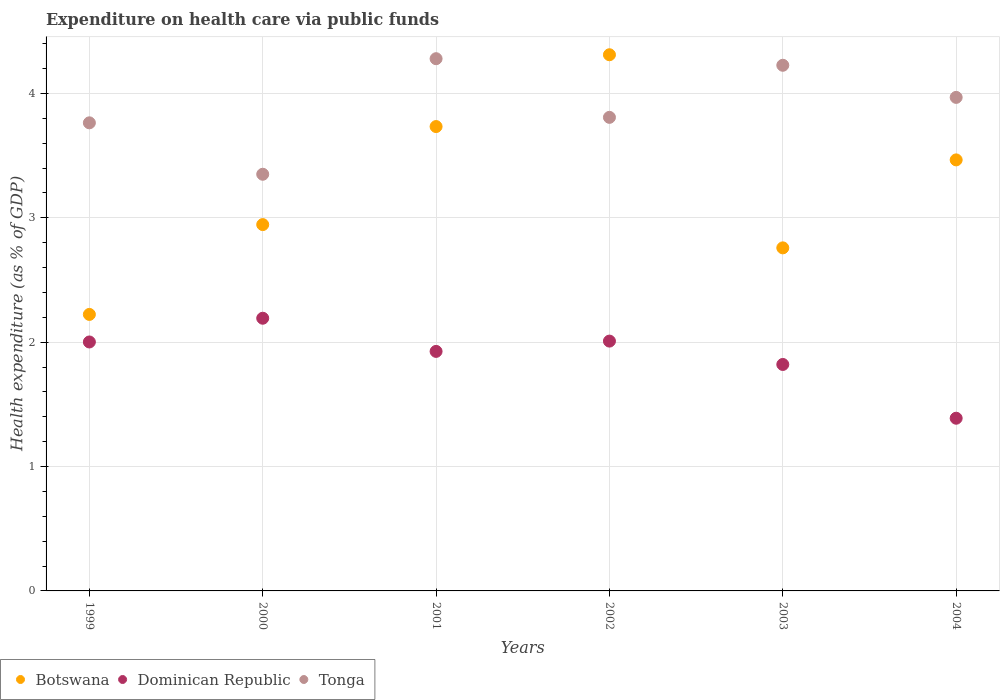How many different coloured dotlines are there?
Give a very brief answer. 3. What is the expenditure made on health care in Tonga in 1999?
Give a very brief answer. 3.76. Across all years, what is the maximum expenditure made on health care in Tonga?
Offer a terse response. 4.28. Across all years, what is the minimum expenditure made on health care in Dominican Republic?
Ensure brevity in your answer.  1.39. What is the total expenditure made on health care in Dominican Republic in the graph?
Offer a terse response. 11.34. What is the difference between the expenditure made on health care in Botswana in 2001 and that in 2003?
Provide a short and direct response. 0.98. What is the difference between the expenditure made on health care in Tonga in 2002 and the expenditure made on health care in Dominican Republic in 1999?
Make the answer very short. 1.81. What is the average expenditure made on health care in Tonga per year?
Make the answer very short. 3.9. In the year 2000, what is the difference between the expenditure made on health care in Botswana and expenditure made on health care in Tonga?
Offer a very short reply. -0.4. In how many years, is the expenditure made on health care in Dominican Republic greater than 0.6000000000000001 %?
Keep it short and to the point. 6. What is the ratio of the expenditure made on health care in Dominican Republic in 2001 to that in 2002?
Provide a succinct answer. 0.96. Is the expenditure made on health care in Botswana in 1999 less than that in 2001?
Your response must be concise. Yes. Is the difference between the expenditure made on health care in Botswana in 1999 and 2000 greater than the difference between the expenditure made on health care in Tonga in 1999 and 2000?
Your answer should be very brief. No. What is the difference between the highest and the second highest expenditure made on health care in Botswana?
Your response must be concise. 0.58. What is the difference between the highest and the lowest expenditure made on health care in Botswana?
Your response must be concise. 2.09. In how many years, is the expenditure made on health care in Tonga greater than the average expenditure made on health care in Tonga taken over all years?
Your answer should be compact. 3. Is the sum of the expenditure made on health care in Tonga in 1999 and 2001 greater than the maximum expenditure made on health care in Botswana across all years?
Make the answer very short. Yes. Is it the case that in every year, the sum of the expenditure made on health care in Tonga and expenditure made on health care in Dominican Republic  is greater than the expenditure made on health care in Botswana?
Your answer should be compact. Yes. Does the expenditure made on health care in Botswana monotonically increase over the years?
Offer a terse response. No. Is the expenditure made on health care in Tonga strictly greater than the expenditure made on health care in Dominican Republic over the years?
Your answer should be compact. Yes. What is the difference between two consecutive major ticks on the Y-axis?
Keep it short and to the point. 1. Are the values on the major ticks of Y-axis written in scientific E-notation?
Provide a short and direct response. No. Does the graph contain any zero values?
Your answer should be very brief. No. Does the graph contain grids?
Make the answer very short. Yes. Where does the legend appear in the graph?
Give a very brief answer. Bottom left. How many legend labels are there?
Offer a terse response. 3. What is the title of the graph?
Offer a very short reply. Expenditure on health care via public funds. Does "Sub-Saharan Africa (all income levels)" appear as one of the legend labels in the graph?
Your answer should be compact. No. What is the label or title of the X-axis?
Your answer should be very brief. Years. What is the label or title of the Y-axis?
Your answer should be compact. Health expenditure (as % of GDP). What is the Health expenditure (as % of GDP) of Botswana in 1999?
Provide a short and direct response. 2.22. What is the Health expenditure (as % of GDP) of Dominican Republic in 1999?
Offer a terse response. 2. What is the Health expenditure (as % of GDP) of Tonga in 1999?
Your answer should be compact. 3.76. What is the Health expenditure (as % of GDP) in Botswana in 2000?
Your answer should be very brief. 2.95. What is the Health expenditure (as % of GDP) of Dominican Republic in 2000?
Your response must be concise. 2.19. What is the Health expenditure (as % of GDP) of Tonga in 2000?
Ensure brevity in your answer.  3.35. What is the Health expenditure (as % of GDP) in Botswana in 2001?
Offer a terse response. 3.73. What is the Health expenditure (as % of GDP) in Dominican Republic in 2001?
Offer a very short reply. 1.93. What is the Health expenditure (as % of GDP) of Tonga in 2001?
Give a very brief answer. 4.28. What is the Health expenditure (as % of GDP) of Botswana in 2002?
Make the answer very short. 4.31. What is the Health expenditure (as % of GDP) of Dominican Republic in 2002?
Your answer should be very brief. 2.01. What is the Health expenditure (as % of GDP) in Tonga in 2002?
Give a very brief answer. 3.81. What is the Health expenditure (as % of GDP) of Botswana in 2003?
Your answer should be very brief. 2.76. What is the Health expenditure (as % of GDP) of Dominican Republic in 2003?
Offer a terse response. 1.82. What is the Health expenditure (as % of GDP) of Tonga in 2003?
Provide a short and direct response. 4.23. What is the Health expenditure (as % of GDP) of Botswana in 2004?
Ensure brevity in your answer.  3.47. What is the Health expenditure (as % of GDP) of Dominican Republic in 2004?
Provide a short and direct response. 1.39. What is the Health expenditure (as % of GDP) in Tonga in 2004?
Your answer should be compact. 3.97. Across all years, what is the maximum Health expenditure (as % of GDP) in Botswana?
Your answer should be compact. 4.31. Across all years, what is the maximum Health expenditure (as % of GDP) in Dominican Republic?
Give a very brief answer. 2.19. Across all years, what is the maximum Health expenditure (as % of GDP) of Tonga?
Offer a very short reply. 4.28. Across all years, what is the minimum Health expenditure (as % of GDP) in Botswana?
Give a very brief answer. 2.22. Across all years, what is the minimum Health expenditure (as % of GDP) of Dominican Republic?
Ensure brevity in your answer.  1.39. Across all years, what is the minimum Health expenditure (as % of GDP) of Tonga?
Offer a terse response. 3.35. What is the total Health expenditure (as % of GDP) of Botswana in the graph?
Provide a short and direct response. 19.44. What is the total Health expenditure (as % of GDP) in Dominican Republic in the graph?
Offer a very short reply. 11.34. What is the total Health expenditure (as % of GDP) in Tonga in the graph?
Offer a terse response. 23.4. What is the difference between the Health expenditure (as % of GDP) of Botswana in 1999 and that in 2000?
Provide a succinct answer. -0.72. What is the difference between the Health expenditure (as % of GDP) of Dominican Republic in 1999 and that in 2000?
Your answer should be compact. -0.19. What is the difference between the Health expenditure (as % of GDP) in Tonga in 1999 and that in 2000?
Keep it short and to the point. 0.41. What is the difference between the Health expenditure (as % of GDP) of Botswana in 1999 and that in 2001?
Ensure brevity in your answer.  -1.51. What is the difference between the Health expenditure (as % of GDP) of Dominican Republic in 1999 and that in 2001?
Provide a short and direct response. 0.08. What is the difference between the Health expenditure (as % of GDP) of Tonga in 1999 and that in 2001?
Your response must be concise. -0.52. What is the difference between the Health expenditure (as % of GDP) of Botswana in 1999 and that in 2002?
Offer a very short reply. -2.09. What is the difference between the Health expenditure (as % of GDP) in Dominican Republic in 1999 and that in 2002?
Offer a very short reply. -0.01. What is the difference between the Health expenditure (as % of GDP) of Tonga in 1999 and that in 2002?
Your answer should be compact. -0.04. What is the difference between the Health expenditure (as % of GDP) of Botswana in 1999 and that in 2003?
Provide a succinct answer. -0.54. What is the difference between the Health expenditure (as % of GDP) in Dominican Republic in 1999 and that in 2003?
Keep it short and to the point. 0.18. What is the difference between the Health expenditure (as % of GDP) in Tonga in 1999 and that in 2003?
Keep it short and to the point. -0.46. What is the difference between the Health expenditure (as % of GDP) of Botswana in 1999 and that in 2004?
Ensure brevity in your answer.  -1.24. What is the difference between the Health expenditure (as % of GDP) of Dominican Republic in 1999 and that in 2004?
Ensure brevity in your answer.  0.61. What is the difference between the Health expenditure (as % of GDP) of Tonga in 1999 and that in 2004?
Your response must be concise. -0.2. What is the difference between the Health expenditure (as % of GDP) of Botswana in 2000 and that in 2001?
Give a very brief answer. -0.79. What is the difference between the Health expenditure (as % of GDP) in Dominican Republic in 2000 and that in 2001?
Keep it short and to the point. 0.27. What is the difference between the Health expenditure (as % of GDP) in Tonga in 2000 and that in 2001?
Offer a very short reply. -0.93. What is the difference between the Health expenditure (as % of GDP) in Botswana in 2000 and that in 2002?
Your answer should be very brief. -1.37. What is the difference between the Health expenditure (as % of GDP) in Dominican Republic in 2000 and that in 2002?
Provide a succinct answer. 0.18. What is the difference between the Health expenditure (as % of GDP) in Tonga in 2000 and that in 2002?
Your response must be concise. -0.46. What is the difference between the Health expenditure (as % of GDP) of Botswana in 2000 and that in 2003?
Keep it short and to the point. 0.19. What is the difference between the Health expenditure (as % of GDP) in Dominican Republic in 2000 and that in 2003?
Offer a terse response. 0.37. What is the difference between the Health expenditure (as % of GDP) in Tonga in 2000 and that in 2003?
Give a very brief answer. -0.88. What is the difference between the Health expenditure (as % of GDP) in Botswana in 2000 and that in 2004?
Ensure brevity in your answer.  -0.52. What is the difference between the Health expenditure (as % of GDP) of Dominican Republic in 2000 and that in 2004?
Offer a very short reply. 0.8. What is the difference between the Health expenditure (as % of GDP) of Tonga in 2000 and that in 2004?
Make the answer very short. -0.62. What is the difference between the Health expenditure (as % of GDP) of Botswana in 2001 and that in 2002?
Give a very brief answer. -0.58. What is the difference between the Health expenditure (as % of GDP) of Dominican Republic in 2001 and that in 2002?
Provide a succinct answer. -0.08. What is the difference between the Health expenditure (as % of GDP) of Tonga in 2001 and that in 2002?
Ensure brevity in your answer.  0.47. What is the difference between the Health expenditure (as % of GDP) in Botswana in 2001 and that in 2003?
Your answer should be very brief. 0.98. What is the difference between the Health expenditure (as % of GDP) in Dominican Republic in 2001 and that in 2003?
Keep it short and to the point. 0.11. What is the difference between the Health expenditure (as % of GDP) in Tonga in 2001 and that in 2003?
Your response must be concise. 0.05. What is the difference between the Health expenditure (as % of GDP) of Botswana in 2001 and that in 2004?
Your response must be concise. 0.27. What is the difference between the Health expenditure (as % of GDP) of Dominican Republic in 2001 and that in 2004?
Offer a very short reply. 0.54. What is the difference between the Health expenditure (as % of GDP) in Tonga in 2001 and that in 2004?
Your answer should be compact. 0.31. What is the difference between the Health expenditure (as % of GDP) in Botswana in 2002 and that in 2003?
Offer a very short reply. 1.55. What is the difference between the Health expenditure (as % of GDP) in Dominican Republic in 2002 and that in 2003?
Offer a terse response. 0.19. What is the difference between the Health expenditure (as % of GDP) of Tonga in 2002 and that in 2003?
Give a very brief answer. -0.42. What is the difference between the Health expenditure (as % of GDP) of Botswana in 2002 and that in 2004?
Keep it short and to the point. 0.85. What is the difference between the Health expenditure (as % of GDP) in Dominican Republic in 2002 and that in 2004?
Ensure brevity in your answer.  0.62. What is the difference between the Health expenditure (as % of GDP) in Tonga in 2002 and that in 2004?
Your answer should be compact. -0.16. What is the difference between the Health expenditure (as % of GDP) of Botswana in 2003 and that in 2004?
Your response must be concise. -0.71. What is the difference between the Health expenditure (as % of GDP) of Dominican Republic in 2003 and that in 2004?
Keep it short and to the point. 0.43. What is the difference between the Health expenditure (as % of GDP) of Tonga in 2003 and that in 2004?
Provide a succinct answer. 0.26. What is the difference between the Health expenditure (as % of GDP) in Botswana in 1999 and the Health expenditure (as % of GDP) in Dominican Republic in 2000?
Offer a terse response. 0.03. What is the difference between the Health expenditure (as % of GDP) in Botswana in 1999 and the Health expenditure (as % of GDP) in Tonga in 2000?
Your response must be concise. -1.13. What is the difference between the Health expenditure (as % of GDP) in Dominican Republic in 1999 and the Health expenditure (as % of GDP) in Tonga in 2000?
Offer a very short reply. -1.35. What is the difference between the Health expenditure (as % of GDP) in Botswana in 1999 and the Health expenditure (as % of GDP) in Dominican Republic in 2001?
Offer a very short reply. 0.3. What is the difference between the Health expenditure (as % of GDP) in Botswana in 1999 and the Health expenditure (as % of GDP) in Tonga in 2001?
Your response must be concise. -2.06. What is the difference between the Health expenditure (as % of GDP) of Dominican Republic in 1999 and the Health expenditure (as % of GDP) of Tonga in 2001?
Make the answer very short. -2.28. What is the difference between the Health expenditure (as % of GDP) of Botswana in 1999 and the Health expenditure (as % of GDP) of Dominican Republic in 2002?
Provide a succinct answer. 0.21. What is the difference between the Health expenditure (as % of GDP) in Botswana in 1999 and the Health expenditure (as % of GDP) in Tonga in 2002?
Give a very brief answer. -1.58. What is the difference between the Health expenditure (as % of GDP) in Dominican Republic in 1999 and the Health expenditure (as % of GDP) in Tonga in 2002?
Provide a short and direct response. -1.81. What is the difference between the Health expenditure (as % of GDP) of Botswana in 1999 and the Health expenditure (as % of GDP) of Dominican Republic in 2003?
Offer a terse response. 0.4. What is the difference between the Health expenditure (as % of GDP) in Botswana in 1999 and the Health expenditure (as % of GDP) in Tonga in 2003?
Provide a succinct answer. -2. What is the difference between the Health expenditure (as % of GDP) of Dominican Republic in 1999 and the Health expenditure (as % of GDP) of Tonga in 2003?
Make the answer very short. -2.22. What is the difference between the Health expenditure (as % of GDP) in Botswana in 1999 and the Health expenditure (as % of GDP) in Dominican Republic in 2004?
Offer a very short reply. 0.83. What is the difference between the Health expenditure (as % of GDP) in Botswana in 1999 and the Health expenditure (as % of GDP) in Tonga in 2004?
Offer a terse response. -1.75. What is the difference between the Health expenditure (as % of GDP) of Dominican Republic in 1999 and the Health expenditure (as % of GDP) of Tonga in 2004?
Your answer should be very brief. -1.97. What is the difference between the Health expenditure (as % of GDP) in Botswana in 2000 and the Health expenditure (as % of GDP) in Dominican Republic in 2001?
Your response must be concise. 1.02. What is the difference between the Health expenditure (as % of GDP) of Botswana in 2000 and the Health expenditure (as % of GDP) of Tonga in 2001?
Give a very brief answer. -1.33. What is the difference between the Health expenditure (as % of GDP) in Dominican Republic in 2000 and the Health expenditure (as % of GDP) in Tonga in 2001?
Give a very brief answer. -2.09. What is the difference between the Health expenditure (as % of GDP) of Botswana in 2000 and the Health expenditure (as % of GDP) of Dominican Republic in 2002?
Your answer should be very brief. 0.94. What is the difference between the Health expenditure (as % of GDP) of Botswana in 2000 and the Health expenditure (as % of GDP) of Tonga in 2002?
Your answer should be compact. -0.86. What is the difference between the Health expenditure (as % of GDP) in Dominican Republic in 2000 and the Health expenditure (as % of GDP) in Tonga in 2002?
Provide a succinct answer. -1.62. What is the difference between the Health expenditure (as % of GDP) of Botswana in 2000 and the Health expenditure (as % of GDP) of Dominican Republic in 2003?
Your answer should be compact. 1.12. What is the difference between the Health expenditure (as % of GDP) in Botswana in 2000 and the Health expenditure (as % of GDP) in Tonga in 2003?
Give a very brief answer. -1.28. What is the difference between the Health expenditure (as % of GDP) of Dominican Republic in 2000 and the Health expenditure (as % of GDP) of Tonga in 2003?
Provide a short and direct response. -2.03. What is the difference between the Health expenditure (as % of GDP) in Botswana in 2000 and the Health expenditure (as % of GDP) in Dominican Republic in 2004?
Keep it short and to the point. 1.56. What is the difference between the Health expenditure (as % of GDP) in Botswana in 2000 and the Health expenditure (as % of GDP) in Tonga in 2004?
Your answer should be very brief. -1.02. What is the difference between the Health expenditure (as % of GDP) in Dominican Republic in 2000 and the Health expenditure (as % of GDP) in Tonga in 2004?
Ensure brevity in your answer.  -1.78. What is the difference between the Health expenditure (as % of GDP) in Botswana in 2001 and the Health expenditure (as % of GDP) in Dominican Republic in 2002?
Provide a short and direct response. 1.73. What is the difference between the Health expenditure (as % of GDP) of Botswana in 2001 and the Health expenditure (as % of GDP) of Tonga in 2002?
Your answer should be compact. -0.07. What is the difference between the Health expenditure (as % of GDP) of Dominican Republic in 2001 and the Health expenditure (as % of GDP) of Tonga in 2002?
Offer a very short reply. -1.88. What is the difference between the Health expenditure (as % of GDP) in Botswana in 2001 and the Health expenditure (as % of GDP) in Dominican Republic in 2003?
Keep it short and to the point. 1.91. What is the difference between the Health expenditure (as % of GDP) in Botswana in 2001 and the Health expenditure (as % of GDP) in Tonga in 2003?
Your answer should be very brief. -0.49. What is the difference between the Health expenditure (as % of GDP) in Dominican Republic in 2001 and the Health expenditure (as % of GDP) in Tonga in 2003?
Your answer should be very brief. -2.3. What is the difference between the Health expenditure (as % of GDP) of Botswana in 2001 and the Health expenditure (as % of GDP) of Dominican Republic in 2004?
Give a very brief answer. 2.35. What is the difference between the Health expenditure (as % of GDP) in Botswana in 2001 and the Health expenditure (as % of GDP) in Tonga in 2004?
Offer a very short reply. -0.23. What is the difference between the Health expenditure (as % of GDP) in Dominican Republic in 2001 and the Health expenditure (as % of GDP) in Tonga in 2004?
Provide a short and direct response. -2.04. What is the difference between the Health expenditure (as % of GDP) of Botswana in 2002 and the Health expenditure (as % of GDP) of Dominican Republic in 2003?
Make the answer very short. 2.49. What is the difference between the Health expenditure (as % of GDP) in Botswana in 2002 and the Health expenditure (as % of GDP) in Tonga in 2003?
Provide a succinct answer. 0.08. What is the difference between the Health expenditure (as % of GDP) in Dominican Republic in 2002 and the Health expenditure (as % of GDP) in Tonga in 2003?
Offer a terse response. -2.22. What is the difference between the Health expenditure (as % of GDP) of Botswana in 2002 and the Health expenditure (as % of GDP) of Dominican Republic in 2004?
Keep it short and to the point. 2.92. What is the difference between the Health expenditure (as % of GDP) of Botswana in 2002 and the Health expenditure (as % of GDP) of Tonga in 2004?
Offer a very short reply. 0.34. What is the difference between the Health expenditure (as % of GDP) in Dominican Republic in 2002 and the Health expenditure (as % of GDP) in Tonga in 2004?
Offer a very short reply. -1.96. What is the difference between the Health expenditure (as % of GDP) in Botswana in 2003 and the Health expenditure (as % of GDP) in Dominican Republic in 2004?
Provide a succinct answer. 1.37. What is the difference between the Health expenditure (as % of GDP) of Botswana in 2003 and the Health expenditure (as % of GDP) of Tonga in 2004?
Offer a terse response. -1.21. What is the difference between the Health expenditure (as % of GDP) of Dominican Republic in 2003 and the Health expenditure (as % of GDP) of Tonga in 2004?
Provide a succinct answer. -2.15. What is the average Health expenditure (as % of GDP) of Botswana per year?
Provide a succinct answer. 3.24. What is the average Health expenditure (as % of GDP) in Dominican Republic per year?
Keep it short and to the point. 1.89. What is the average Health expenditure (as % of GDP) of Tonga per year?
Offer a very short reply. 3.9. In the year 1999, what is the difference between the Health expenditure (as % of GDP) in Botswana and Health expenditure (as % of GDP) in Dominican Republic?
Ensure brevity in your answer.  0.22. In the year 1999, what is the difference between the Health expenditure (as % of GDP) of Botswana and Health expenditure (as % of GDP) of Tonga?
Keep it short and to the point. -1.54. In the year 1999, what is the difference between the Health expenditure (as % of GDP) in Dominican Republic and Health expenditure (as % of GDP) in Tonga?
Offer a very short reply. -1.76. In the year 2000, what is the difference between the Health expenditure (as % of GDP) in Botswana and Health expenditure (as % of GDP) in Dominican Republic?
Offer a very short reply. 0.75. In the year 2000, what is the difference between the Health expenditure (as % of GDP) in Botswana and Health expenditure (as % of GDP) in Tonga?
Give a very brief answer. -0.4. In the year 2000, what is the difference between the Health expenditure (as % of GDP) in Dominican Republic and Health expenditure (as % of GDP) in Tonga?
Offer a very short reply. -1.16. In the year 2001, what is the difference between the Health expenditure (as % of GDP) of Botswana and Health expenditure (as % of GDP) of Dominican Republic?
Provide a succinct answer. 1.81. In the year 2001, what is the difference between the Health expenditure (as % of GDP) of Botswana and Health expenditure (as % of GDP) of Tonga?
Your answer should be very brief. -0.55. In the year 2001, what is the difference between the Health expenditure (as % of GDP) in Dominican Republic and Health expenditure (as % of GDP) in Tonga?
Keep it short and to the point. -2.35. In the year 2002, what is the difference between the Health expenditure (as % of GDP) in Botswana and Health expenditure (as % of GDP) in Dominican Republic?
Offer a very short reply. 2.3. In the year 2002, what is the difference between the Health expenditure (as % of GDP) of Botswana and Health expenditure (as % of GDP) of Tonga?
Your answer should be compact. 0.5. In the year 2002, what is the difference between the Health expenditure (as % of GDP) of Dominican Republic and Health expenditure (as % of GDP) of Tonga?
Your response must be concise. -1.8. In the year 2003, what is the difference between the Health expenditure (as % of GDP) in Botswana and Health expenditure (as % of GDP) in Dominican Republic?
Give a very brief answer. 0.94. In the year 2003, what is the difference between the Health expenditure (as % of GDP) in Botswana and Health expenditure (as % of GDP) in Tonga?
Your answer should be very brief. -1.47. In the year 2003, what is the difference between the Health expenditure (as % of GDP) in Dominican Republic and Health expenditure (as % of GDP) in Tonga?
Provide a short and direct response. -2.41. In the year 2004, what is the difference between the Health expenditure (as % of GDP) of Botswana and Health expenditure (as % of GDP) of Dominican Republic?
Your answer should be compact. 2.08. In the year 2004, what is the difference between the Health expenditure (as % of GDP) of Botswana and Health expenditure (as % of GDP) of Tonga?
Keep it short and to the point. -0.5. In the year 2004, what is the difference between the Health expenditure (as % of GDP) of Dominican Republic and Health expenditure (as % of GDP) of Tonga?
Ensure brevity in your answer.  -2.58. What is the ratio of the Health expenditure (as % of GDP) in Botswana in 1999 to that in 2000?
Your answer should be very brief. 0.75. What is the ratio of the Health expenditure (as % of GDP) of Dominican Republic in 1999 to that in 2000?
Your answer should be compact. 0.91. What is the ratio of the Health expenditure (as % of GDP) of Tonga in 1999 to that in 2000?
Your answer should be compact. 1.12. What is the ratio of the Health expenditure (as % of GDP) of Botswana in 1999 to that in 2001?
Provide a short and direct response. 0.6. What is the ratio of the Health expenditure (as % of GDP) in Dominican Republic in 1999 to that in 2001?
Give a very brief answer. 1.04. What is the ratio of the Health expenditure (as % of GDP) of Tonga in 1999 to that in 2001?
Your response must be concise. 0.88. What is the ratio of the Health expenditure (as % of GDP) in Botswana in 1999 to that in 2002?
Provide a succinct answer. 0.52. What is the ratio of the Health expenditure (as % of GDP) of Tonga in 1999 to that in 2002?
Your answer should be compact. 0.99. What is the ratio of the Health expenditure (as % of GDP) in Botswana in 1999 to that in 2003?
Ensure brevity in your answer.  0.81. What is the ratio of the Health expenditure (as % of GDP) in Dominican Republic in 1999 to that in 2003?
Make the answer very short. 1.1. What is the ratio of the Health expenditure (as % of GDP) in Tonga in 1999 to that in 2003?
Your answer should be very brief. 0.89. What is the ratio of the Health expenditure (as % of GDP) of Botswana in 1999 to that in 2004?
Offer a terse response. 0.64. What is the ratio of the Health expenditure (as % of GDP) in Dominican Republic in 1999 to that in 2004?
Give a very brief answer. 1.44. What is the ratio of the Health expenditure (as % of GDP) in Tonga in 1999 to that in 2004?
Your answer should be very brief. 0.95. What is the ratio of the Health expenditure (as % of GDP) of Botswana in 2000 to that in 2001?
Your response must be concise. 0.79. What is the ratio of the Health expenditure (as % of GDP) of Dominican Republic in 2000 to that in 2001?
Provide a succinct answer. 1.14. What is the ratio of the Health expenditure (as % of GDP) in Tonga in 2000 to that in 2001?
Your response must be concise. 0.78. What is the ratio of the Health expenditure (as % of GDP) in Botswana in 2000 to that in 2002?
Give a very brief answer. 0.68. What is the ratio of the Health expenditure (as % of GDP) of Dominican Republic in 2000 to that in 2002?
Provide a short and direct response. 1.09. What is the ratio of the Health expenditure (as % of GDP) in Tonga in 2000 to that in 2002?
Keep it short and to the point. 0.88. What is the ratio of the Health expenditure (as % of GDP) of Botswana in 2000 to that in 2003?
Give a very brief answer. 1.07. What is the ratio of the Health expenditure (as % of GDP) of Dominican Republic in 2000 to that in 2003?
Keep it short and to the point. 1.2. What is the ratio of the Health expenditure (as % of GDP) in Tonga in 2000 to that in 2003?
Your response must be concise. 0.79. What is the ratio of the Health expenditure (as % of GDP) of Botswana in 2000 to that in 2004?
Your answer should be very brief. 0.85. What is the ratio of the Health expenditure (as % of GDP) of Dominican Republic in 2000 to that in 2004?
Provide a succinct answer. 1.58. What is the ratio of the Health expenditure (as % of GDP) in Tonga in 2000 to that in 2004?
Offer a terse response. 0.84. What is the ratio of the Health expenditure (as % of GDP) in Botswana in 2001 to that in 2002?
Give a very brief answer. 0.87. What is the ratio of the Health expenditure (as % of GDP) of Dominican Republic in 2001 to that in 2002?
Make the answer very short. 0.96. What is the ratio of the Health expenditure (as % of GDP) of Tonga in 2001 to that in 2002?
Offer a very short reply. 1.12. What is the ratio of the Health expenditure (as % of GDP) in Botswana in 2001 to that in 2003?
Offer a very short reply. 1.35. What is the ratio of the Health expenditure (as % of GDP) in Dominican Republic in 2001 to that in 2003?
Offer a terse response. 1.06. What is the ratio of the Health expenditure (as % of GDP) in Tonga in 2001 to that in 2003?
Your answer should be very brief. 1.01. What is the ratio of the Health expenditure (as % of GDP) in Botswana in 2001 to that in 2004?
Keep it short and to the point. 1.08. What is the ratio of the Health expenditure (as % of GDP) in Dominican Republic in 2001 to that in 2004?
Ensure brevity in your answer.  1.39. What is the ratio of the Health expenditure (as % of GDP) of Tonga in 2001 to that in 2004?
Your answer should be very brief. 1.08. What is the ratio of the Health expenditure (as % of GDP) of Botswana in 2002 to that in 2003?
Keep it short and to the point. 1.56. What is the ratio of the Health expenditure (as % of GDP) in Dominican Republic in 2002 to that in 2003?
Offer a very short reply. 1.1. What is the ratio of the Health expenditure (as % of GDP) of Tonga in 2002 to that in 2003?
Give a very brief answer. 0.9. What is the ratio of the Health expenditure (as % of GDP) of Botswana in 2002 to that in 2004?
Provide a succinct answer. 1.24. What is the ratio of the Health expenditure (as % of GDP) in Dominican Republic in 2002 to that in 2004?
Your response must be concise. 1.45. What is the ratio of the Health expenditure (as % of GDP) of Tonga in 2002 to that in 2004?
Ensure brevity in your answer.  0.96. What is the ratio of the Health expenditure (as % of GDP) of Botswana in 2003 to that in 2004?
Keep it short and to the point. 0.8. What is the ratio of the Health expenditure (as % of GDP) of Dominican Republic in 2003 to that in 2004?
Your answer should be compact. 1.31. What is the ratio of the Health expenditure (as % of GDP) in Tonga in 2003 to that in 2004?
Make the answer very short. 1.07. What is the difference between the highest and the second highest Health expenditure (as % of GDP) in Botswana?
Make the answer very short. 0.58. What is the difference between the highest and the second highest Health expenditure (as % of GDP) in Dominican Republic?
Offer a very short reply. 0.18. What is the difference between the highest and the second highest Health expenditure (as % of GDP) of Tonga?
Give a very brief answer. 0.05. What is the difference between the highest and the lowest Health expenditure (as % of GDP) of Botswana?
Offer a very short reply. 2.09. What is the difference between the highest and the lowest Health expenditure (as % of GDP) in Dominican Republic?
Offer a terse response. 0.8. What is the difference between the highest and the lowest Health expenditure (as % of GDP) of Tonga?
Make the answer very short. 0.93. 